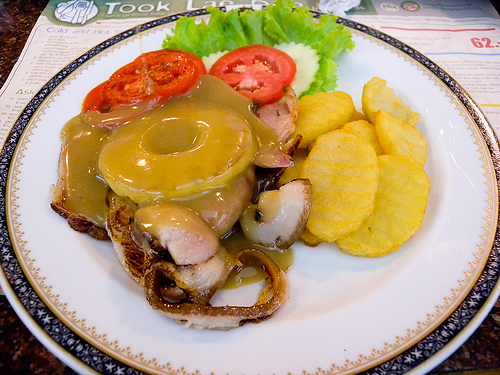<image>
Is there a pineapple in the tomato? No. The pineapple is not contained within the tomato. These objects have a different spatial relationship. 